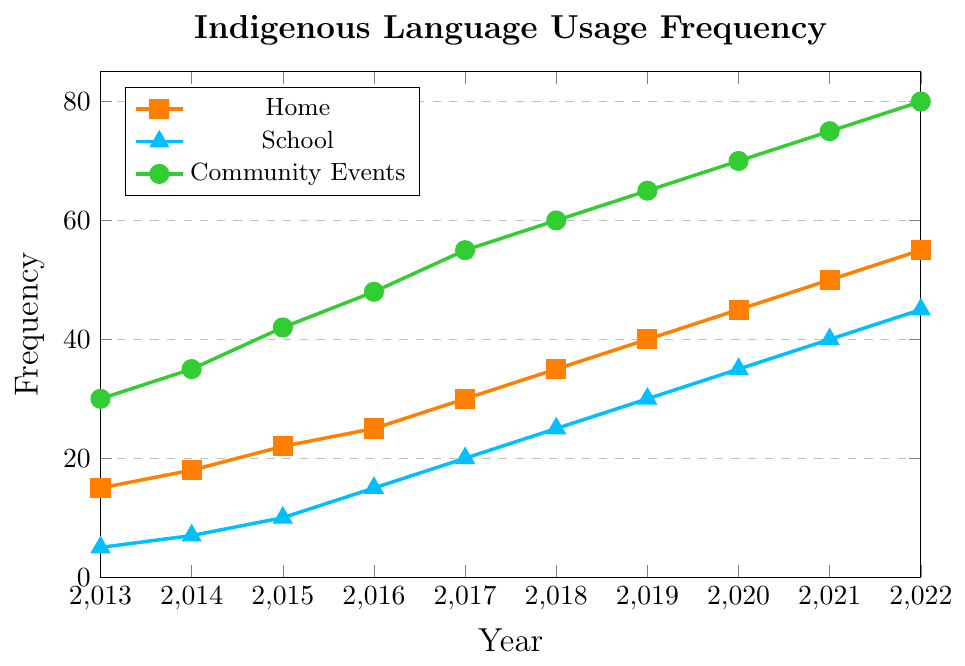What is the frequency of Indigenous language usage at home in 2015? From the plot, follow the "home" line (orange with square markers) to the year 2015, and observe that it intersects at the value 22.
Answer: 22 Comparing 2014, in which social context was Indigenous language usage the highest? In 2014, intersect the year with each context line: home (orange) reaches 18, school (blue) reaches 7, community events (green) reaches 35. The highest value is for community events.
Answer: Community events Between 2015 and 2016, which social context saw the largest increase in Indigenous language usage? Calculate the differences for each context: home (2016-2015 = 25-22 = 3), school (15-10 = 5), community events (48-42 = 6). Community events saw the largest increase of 6.
Answer: Community events What is the average frequency of Indigenous language usage in schools from 2018 to 2020? Add up the values for school from 2018, 2019, and 2020: (25 + 30 + 35 = 90). Divide by the number of years (3): 90/3 = 30.
Answer: 30 Which year had the equal frequency of Indigenous language usage at school and community events? Follow both the school (blue) and community events (green) lines until they intersect where values are equal. This occurs in 2022 when both reach 45 and 80 respectively.
Answer: None What is the difference in frequency between home and school contexts in 2020? Find the values for home (45) and school (35) in 2020: 45 - 35 = 10
Answer: 10 How much has the frequency of Indigenous language usage at community events increased from 2013 to 2022? Subtract the 2013 value (30) from the 2022 value (80) for community events: 80 - 30 = 50
Answer: 50 What is the combined frequency of Indigenous language usage at home and community events in the year 2021? Add the values for home (50) and community events (75) in 2021: 50 + 75 = 125
Answer: 125 